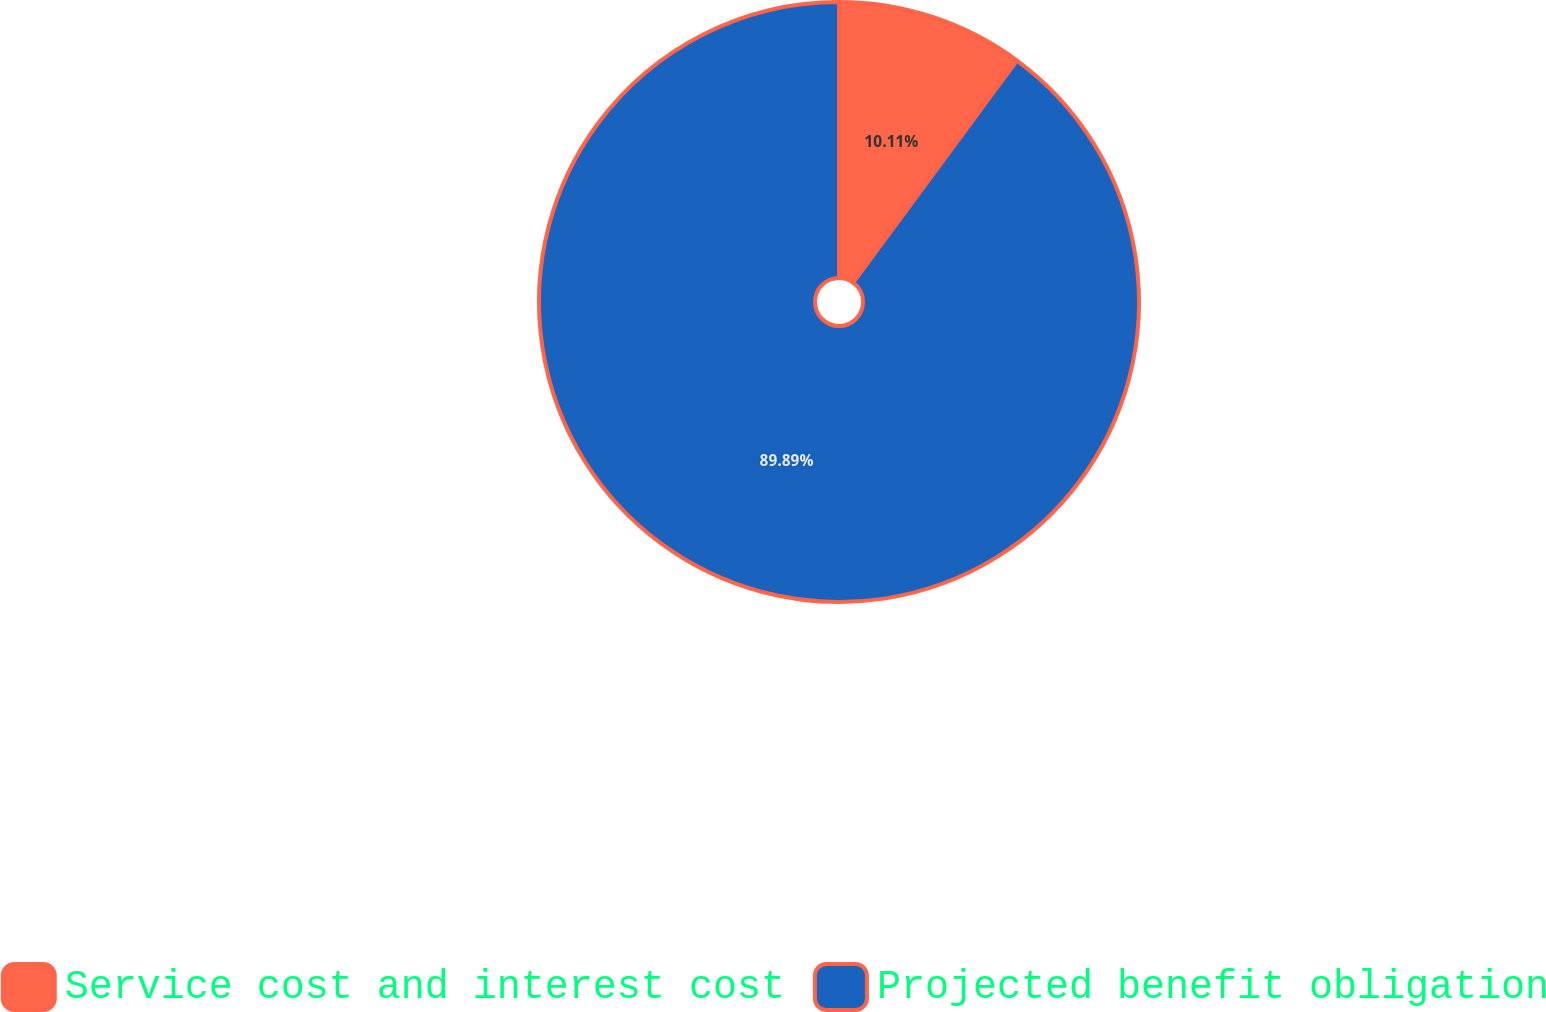<chart> <loc_0><loc_0><loc_500><loc_500><pie_chart><fcel>Service cost and interest cost<fcel>Projected benefit obligation<nl><fcel>10.11%<fcel>89.89%<nl></chart> 